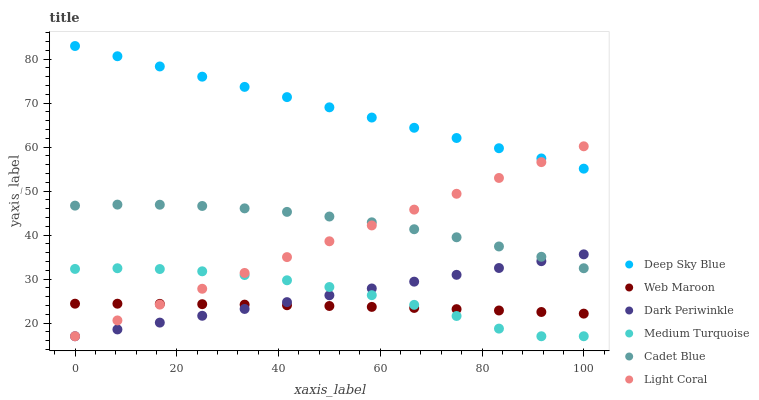Does Web Maroon have the minimum area under the curve?
Answer yes or no. Yes. Does Deep Sky Blue have the maximum area under the curve?
Answer yes or no. Yes. Does Deep Sky Blue have the minimum area under the curve?
Answer yes or no. No. Does Web Maroon have the maximum area under the curve?
Answer yes or no. No. Is Light Coral the smoothest?
Answer yes or no. Yes. Is Medium Turquoise the roughest?
Answer yes or no. Yes. Is Deep Sky Blue the smoothest?
Answer yes or no. No. Is Deep Sky Blue the roughest?
Answer yes or no. No. Does Light Coral have the lowest value?
Answer yes or no. Yes. Does Web Maroon have the lowest value?
Answer yes or no. No. Does Deep Sky Blue have the highest value?
Answer yes or no. Yes. Does Web Maroon have the highest value?
Answer yes or no. No. Is Cadet Blue less than Deep Sky Blue?
Answer yes or no. Yes. Is Deep Sky Blue greater than Dark Periwinkle?
Answer yes or no. Yes. Does Dark Periwinkle intersect Medium Turquoise?
Answer yes or no. Yes. Is Dark Periwinkle less than Medium Turquoise?
Answer yes or no. No. Is Dark Periwinkle greater than Medium Turquoise?
Answer yes or no. No. Does Cadet Blue intersect Deep Sky Blue?
Answer yes or no. No. 